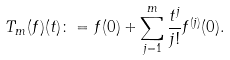Convert formula to latex. <formula><loc_0><loc_0><loc_500><loc_500>T _ { m } ( f ) ( t ) \colon = f ( 0 ) + \sum _ { j = 1 } ^ { m } \frac { t ^ { j } } { j ! } f ^ { ( j ) } ( 0 ) .</formula> 